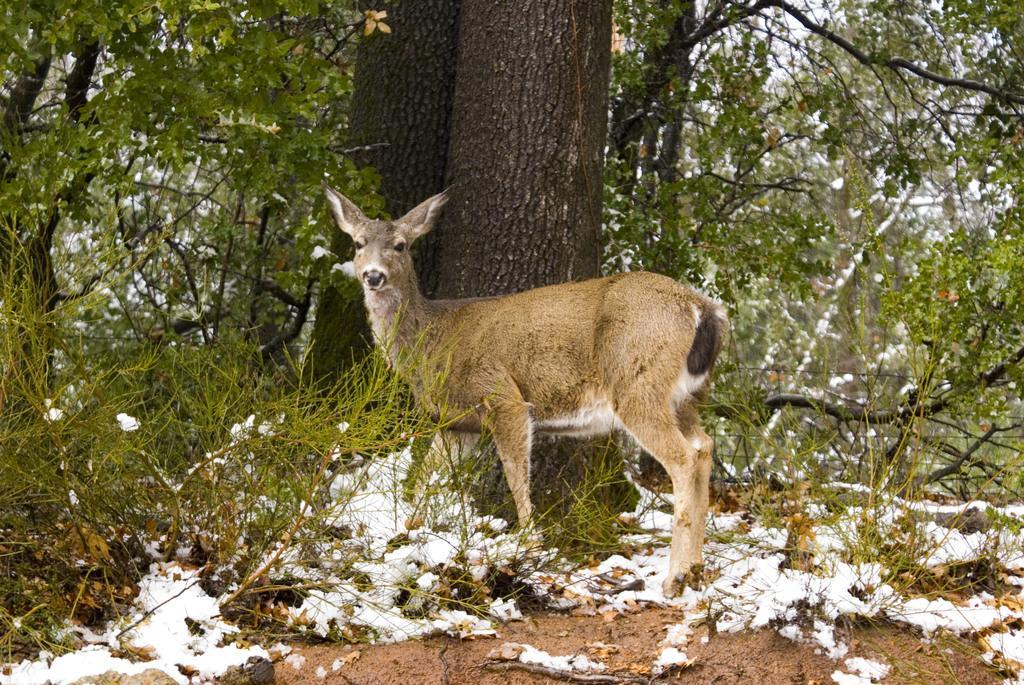In one or two sentences, can you explain what this image depicts? In this image we can see an animal on the ground. We can also see the bark of the trees, a group of trees and the sky. 